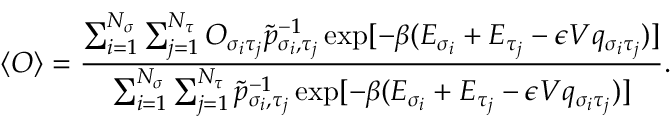<formula> <loc_0><loc_0><loc_500><loc_500>\langle O \rangle = \frac { \sum _ { i = 1 } ^ { N _ { \sigma } } \sum _ { j = 1 } ^ { N _ { \tau } } O _ { \sigma _ { i } \tau _ { j } } \tilde { p } _ { \sigma _ { i } , \tau _ { j } } ^ { - 1 } \exp [ - \beta ( E _ { \sigma _ { i } } + E _ { \tau _ { j } } - \epsilon V q _ { \sigma _ { i } \tau _ { j } } ) ] } { \sum _ { i = 1 } ^ { N _ { \sigma } } \sum _ { j = 1 } ^ { N _ { \tau } } \tilde { p } _ { \sigma _ { i } , \tau _ { j } } ^ { - 1 } \exp [ - \beta ( E _ { \sigma _ { i } } + E _ { \tau _ { j } } - \epsilon V q _ { \sigma _ { i } \tau _ { j } } ) ] } .</formula> 